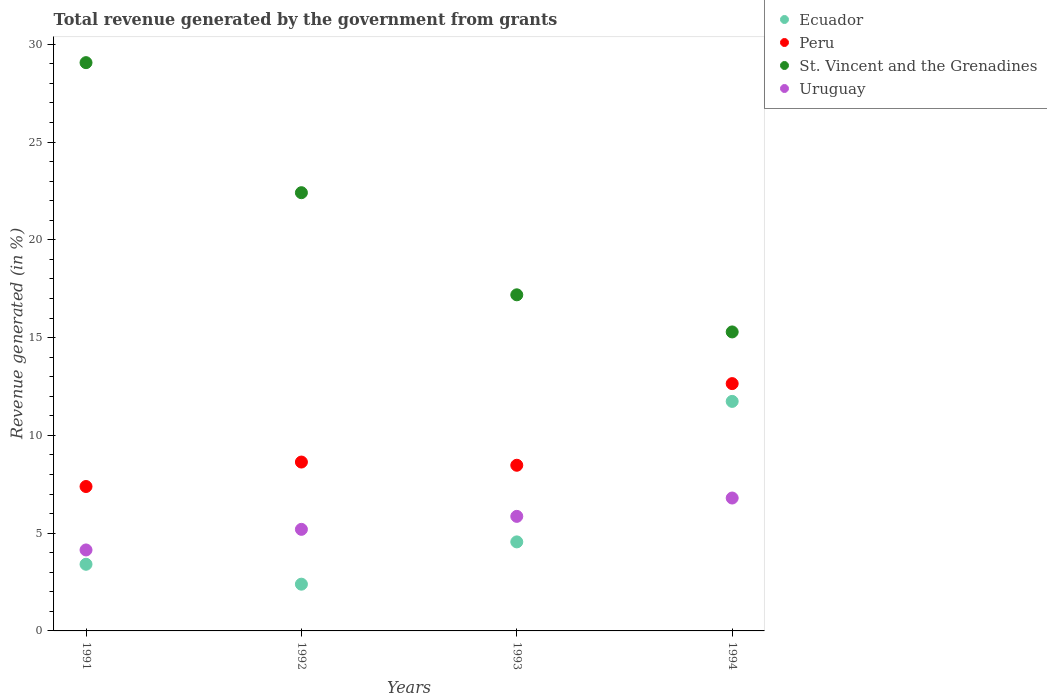How many different coloured dotlines are there?
Provide a succinct answer. 4. Is the number of dotlines equal to the number of legend labels?
Provide a short and direct response. Yes. What is the total revenue generated in Uruguay in 1991?
Your response must be concise. 4.14. Across all years, what is the maximum total revenue generated in Peru?
Make the answer very short. 12.65. Across all years, what is the minimum total revenue generated in St. Vincent and the Grenadines?
Your answer should be compact. 15.29. In which year was the total revenue generated in Ecuador minimum?
Your answer should be very brief. 1992. What is the total total revenue generated in Uruguay in the graph?
Make the answer very short. 21.99. What is the difference between the total revenue generated in St. Vincent and the Grenadines in 1991 and that in 1992?
Your response must be concise. 6.65. What is the difference between the total revenue generated in St. Vincent and the Grenadines in 1993 and the total revenue generated in Ecuador in 1991?
Offer a very short reply. 13.78. What is the average total revenue generated in Uruguay per year?
Offer a terse response. 5.5. In the year 1993, what is the difference between the total revenue generated in St. Vincent and the Grenadines and total revenue generated in Uruguay?
Your response must be concise. 11.33. In how many years, is the total revenue generated in St. Vincent and the Grenadines greater than 9 %?
Make the answer very short. 4. What is the ratio of the total revenue generated in Uruguay in 1991 to that in 1993?
Provide a short and direct response. 0.71. Is the total revenue generated in Peru in 1992 less than that in 1994?
Ensure brevity in your answer.  Yes. Is the difference between the total revenue generated in St. Vincent and the Grenadines in 1991 and 1993 greater than the difference between the total revenue generated in Uruguay in 1991 and 1993?
Ensure brevity in your answer.  Yes. What is the difference between the highest and the second highest total revenue generated in Uruguay?
Give a very brief answer. 0.94. What is the difference between the highest and the lowest total revenue generated in St. Vincent and the Grenadines?
Provide a succinct answer. 13.77. Is the sum of the total revenue generated in Peru in 1991 and 1992 greater than the maximum total revenue generated in St. Vincent and the Grenadines across all years?
Your answer should be very brief. No. Is the total revenue generated in Uruguay strictly less than the total revenue generated in Ecuador over the years?
Your response must be concise. No. How many dotlines are there?
Provide a short and direct response. 4. Does the graph contain any zero values?
Give a very brief answer. No. Does the graph contain grids?
Your answer should be compact. No. How many legend labels are there?
Offer a very short reply. 4. What is the title of the graph?
Your answer should be compact. Total revenue generated by the government from grants. What is the label or title of the X-axis?
Offer a very short reply. Years. What is the label or title of the Y-axis?
Ensure brevity in your answer.  Revenue generated (in %). What is the Revenue generated (in %) of Ecuador in 1991?
Keep it short and to the point. 3.41. What is the Revenue generated (in %) in Peru in 1991?
Your response must be concise. 7.38. What is the Revenue generated (in %) of St. Vincent and the Grenadines in 1991?
Keep it short and to the point. 29.06. What is the Revenue generated (in %) in Uruguay in 1991?
Provide a succinct answer. 4.14. What is the Revenue generated (in %) in Ecuador in 1992?
Keep it short and to the point. 2.39. What is the Revenue generated (in %) of Peru in 1992?
Provide a succinct answer. 8.64. What is the Revenue generated (in %) in St. Vincent and the Grenadines in 1992?
Your answer should be very brief. 22.41. What is the Revenue generated (in %) of Uruguay in 1992?
Offer a terse response. 5.19. What is the Revenue generated (in %) in Ecuador in 1993?
Keep it short and to the point. 4.55. What is the Revenue generated (in %) in Peru in 1993?
Your answer should be compact. 8.47. What is the Revenue generated (in %) of St. Vincent and the Grenadines in 1993?
Provide a short and direct response. 17.19. What is the Revenue generated (in %) in Uruguay in 1993?
Offer a terse response. 5.86. What is the Revenue generated (in %) in Ecuador in 1994?
Your answer should be compact. 11.74. What is the Revenue generated (in %) in Peru in 1994?
Provide a short and direct response. 12.65. What is the Revenue generated (in %) of St. Vincent and the Grenadines in 1994?
Your answer should be very brief. 15.29. What is the Revenue generated (in %) in Uruguay in 1994?
Your answer should be compact. 6.8. Across all years, what is the maximum Revenue generated (in %) of Ecuador?
Provide a short and direct response. 11.74. Across all years, what is the maximum Revenue generated (in %) of Peru?
Keep it short and to the point. 12.65. Across all years, what is the maximum Revenue generated (in %) of St. Vincent and the Grenadines?
Offer a terse response. 29.06. Across all years, what is the maximum Revenue generated (in %) in Uruguay?
Your answer should be compact. 6.8. Across all years, what is the minimum Revenue generated (in %) in Ecuador?
Your answer should be compact. 2.39. Across all years, what is the minimum Revenue generated (in %) of Peru?
Keep it short and to the point. 7.38. Across all years, what is the minimum Revenue generated (in %) of St. Vincent and the Grenadines?
Your answer should be compact. 15.29. Across all years, what is the minimum Revenue generated (in %) of Uruguay?
Your response must be concise. 4.14. What is the total Revenue generated (in %) of Ecuador in the graph?
Offer a very short reply. 22.09. What is the total Revenue generated (in %) in Peru in the graph?
Ensure brevity in your answer.  37.14. What is the total Revenue generated (in %) in St. Vincent and the Grenadines in the graph?
Your response must be concise. 83.95. What is the total Revenue generated (in %) of Uruguay in the graph?
Ensure brevity in your answer.  21.99. What is the difference between the Revenue generated (in %) of Ecuador in 1991 and that in 1992?
Keep it short and to the point. 1.02. What is the difference between the Revenue generated (in %) in Peru in 1991 and that in 1992?
Offer a terse response. -1.25. What is the difference between the Revenue generated (in %) in St. Vincent and the Grenadines in 1991 and that in 1992?
Ensure brevity in your answer.  6.65. What is the difference between the Revenue generated (in %) in Uruguay in 1991 and that in 1992?
Provide a short and direct response. -1.05. What is the difference between the Revenue generated (in %) of Ecuador in 1991 and that in 1993?
Your answer should be very brief. -1.14. What is the difference between the Revenue generated (in %) of Peru in 1991 and that in 1993?
Keep it short and to the point. -1.09. What is the difference between the Revenue generated (in %) of St. Vincent and the Grenadines in 1991 and that in 1993?
Offer a terse response. 11.87. What is the difference between the Revenue generated (in %) in Uruguay in 1991 and that in 1993?
Your answer should be compact. -1.72. What is the difference between the Revenue generated (in %) of Ecuador in 1991 and that in 1994?
Your answer should be compact. -8.33. What is the difference between the Revenue generated (in %) of Peru in 1991 and that in 1994?
Your response must be concise. -5.26. What is the difference between the Revenue generated (in %) in St. Vincent and the Grenadines in 1991 and that in 1994?
Keep it short and to the point. 13.77. What is the difference between the Revenue generated (in %) in Uruguay in 1991 and that in 1994?
Ensure brevity in your answer.  -2.66. What is the difference between the Revenue generated (in %) in Ecuador in 1992 and that in 1993?
Your answer should be compact. -2.16. What is the difference between the Revenue generated (in %) of Peru in 1992 and that in 1993?
Offer a very short reply. 0.16. What is the difference between the Revenue generated (in %) of St. Vincent and the Grenadines in 1992 and that in 1993?
Your answer should be compact. 5.22. What is the difference between the Revenue generated (in %) in Uruguay in 1992 and that in 1993?
Provide a short and direct response. -0.66. What is the difference between the Revenue generated (in %) of Ecuador in 1992 and that in 1994?
Offer a terse response. -9.35. What is the difference between the Revenue generated (in %) in Peru in 1992 and that in 1994?
Your answer should be compact. -4.01. What is the difference between the Revenue generated (in %) in St. Vincent and the Grenadines in 1992 and that in 1994?
Your answer should be compact. 7.12. What is the difference between the Revenue generated (in %) in Uruguay in 1992 and that in 1994?
Make the answer very short. -1.6. What is the difference between the Revenue generated (in %) in Ecuador in 1993 and that in 1994?
Give a very brief answer. -7.18. What is the difference between the Revenue generated (in %) in Peru in 1993 and that in 1994?
Your answer should be very brief. -4.18. What is the difference between the Revenue generated (in %) of St. Vincent and the Grenadines in 1993 and that in 1994?
Provide a short and direct response. 1.9. What is the difference between the Revenue generated (in %) of Uruguay in 1993 and that in 1994?
Give a very brief answer. -0.94. What is the difference between the Revenue generated (in %) of Ecuador in 1991 and the Revenue generated (in %) of Peru in 1992?
Provide a short and direct response. -5.23. What is the difference between the Revenue generated (in %) of Ecuador in 1991 and the Revenue generated (in %) of St. Vincent and the Grenadines in 1992?
Your answer should be very brief. -19. What is the difference between the Revenue generated (in %) of Ecuador in 1991 and the Revenue generated (in %) of Uruguay in 1992?
Keep it short and to the point. -1.79. What is the difference between the Revenue generated (in %) of Peru in 1991 and the Revenue generated (in %) of St. Vincent and the Grenadines in 1992?
Your response must be concise. -15.02. What is the difference between the Revenue generated (in %) in Peru in 1991 and the Revenue generated (in %) in Uruguay in 1992?
Offer a terse response. 2.19. What is the difference between the Revenue generated (in %) in St. Vincent and the Grenadines in 1991 and the Revenue generated (in %) in Uruguay in 1992?
Make the answer very short. 23.87. What is the difference between the Revenue generated (in %) in Ecuador in 1991 and the Revenue generated (in %) in Peru in 1993?
Ensure brevity in your answer.  -5.06. What is the difference between the Revenue generated (in %) of Ecuador in 1991 and the Revenue generated (in %) of St. Vincent and the Grenadines in 1993?
Keep it short and to the point. -13.78. What is the difference between the Revenue generated (in %) in Ecuador in 1991 and the Revenue generated (in %) in Uruguay in 1993?
Provide a succinct answer. -2.45. What is the difference between the Revenue generated (in %) of Peru in 1991 and the Revenue generated (in %) of St. Vincent and the Grenadines in 1993?
Your answer should be very brief. -9.8. What is the difference between the Revenue generated (in %) in Peru in 1991 and the Revenue generated (in %) in Uruguay in 1993?
Offer a terse response. 1.53. What is the difference between the Revenue generated (in %) in St. Vincent and the Grenadines in 1991 and the Revenue generated (in %) in Uruguay in 1993?
Keep it short and to the point. 23.2. What is the difference between the Revenue generated (in %) of Ecuador in 1991 and the Revenue generated (in %) of Peru in 1994?
Offer a very short reply. -9.24. What is the difference between the Revenue generated (in %) in Ecuador in 1991 and the Revenue generated (in %) in St. Vincent and the Grenadines in 1994?
Give a very brief answer. -11.88. What is the difference between the Revenue generated (in %) of Ecuador in 1991 and the Revenue generated (in %) of Uruguay in 1994?
Provide a short and direct response. -3.39. What is the difference between the Revenue generated (in %) in Peru in 1991 and the Revenue generated (in %) in St. Vincent and the Grenadines in 1994?
Provide a succinct answer. -7.9. What is the difference between the Revenue generated (in %) of Peru in 1991 and the Revenue generated (in %) of Uruguay in 1994?
Keep it short and to the point. 0.59. What is the difference between the Revenue generated (in %) of St. Vincent and the Grenadines in 1991 and the Revenue generated (in %) of Uruguay in 1994?
Give a very brief answer. 22.26. What is the difference between the Revenue generated (in %) in Ecuador in 1992 and the Revenue generated (in %) in Peru in 1993?
Keep it short and to the point. -6.08. What is the difference between the Revenue generated (in %) in Ecuador in 1992 and the Revenue generated (in %) in St. Vincent and the Grenadines in 1993?
Give a very brief answer. -14.8. What is the difference between the Revenue generated (in %) of Ecuador in 1992 and the Revenue generated (in %) of Uruguay in 1993?
Your answer should be very brief. -3.47. What is the difference between the Revenue generated (in %) in Peru in 1992 and the Revenue generated (in %) in St. Vincent and the Grenadines in 1993?
Your response must be concise. -8.55. What is the difference between the Revenue generated (in %) of Peru in 1992 and the Revenue generated (in %) of Uruguay in 1993?
Ensure brevity in your answer.  2.78. What is the difference between the Revenue generated (in %) in St. Vincent and the Grenadines in 1992 and the Revenue generated (in %) in Uruguay in 1993?
Provide a succinct answer. 16.55. What is the difference between the Revenue generated (in %) in Ecuador in 1992 and the Revenue generated (in %) in Peru in 1994?
Your answer should be very brief. -10.26. What is the difference between the Revenue generated (in %) of Ecuador in 1992 and the Revenue generated (in %) of St. Vincent and the Grenadines in 1994?
Your answer should be very brief. -12.9. What is the difference between the Revenue generated (in %) of Ecuador in 1992 and the Revenue generated (in %) of Uruguay in 1994?
Offer a very short reply. -4.41. What is the difference between the Revenue generated (in %) in Peru in 1992 and the Revenue generated (in %) in St. Vincent and the Grenadines in 1994?
Ensure brevity in your answer.  -6.65. What is the difference between the Revenue generated (in %) of Peru in 1992 and the Revenue generated (in %) of Uruguay in 1994?
Your response must be concise. 1.84. What is the difference between the Revenue generated (in %) in St. Vincent and the Grenadines in 1992 and the Revenue generated (in %) in Uruguay in 1994?
Provide a succinct answer. 15.61. What is the difference between the Revenue generated (in %) of Ecuador in 1993 and the Revenue generated (in %) of Peru in 1994?
Keep it short and to the point. -8.09. What is the difference between the Revenue generated (in %) of Ecuador in 1993 and the Revenue generated (in %) of St. Vincent and the Grenadines in 1994?
Ensure brevity in your answer.  -10.74. What is the difference between the Revenue generated (in %) in Ecuador in 1993 and the Revenue generated (in %) in Uruguay in 1994?
Make the answer very short. -2.24. What is the difference between the Revenue generated (in %) of Peru in 1993 and the Revenue generated (in %) of St. Vincent and the Grenadines in 1994?
Offer a very short reply. -6.82. What is the difference between the Revenue generated (in %) in Peru in 1993 and the Revenue generated (in %) in Uruguay in 1994?
Your response must be concise. 1.68. What is the difference between the Revenue generated (in %) of St. Vincent and the Grenadines in 1993 and the Revenue generated (in %) of Uruguay in 1994?
Ensure brevity in your answer.  10.39. What is the average Revenue generated (in %) in Ecuador per year?
Keep it short and to the point. 5.52. What is the average Revenue generated (in %) of Peru per year?
Make the answer very short. 9.28. What is the average Revenue generated (in %) in St. Vincent and the Grenadines per year?
Provide a succinct answer. 20.99. What is the average Revenue generated (in %) in Uruguay per year?
Give a very brief answer. 5.5. In the year 1991, what is the difference between the Revenue generated (in %) of Ecuador and Revenue generated (in %) of Peru?
Your answer should be very brief. -3.98. In the year 1991, what is the difference between the Revenue generated (in %) in Ecuador and Revenue generated (in %) in St. Vincent and the Grenadines?
Your response must be concise. -25.65. In the year 1991, what is the difference between the Revenue generated (in %) of Ecuador and Revenue generated (in %) of Uruguay?
Keep it short and to the point. -0.73. In the year 1991, what is the difference between the Revenue generated (in %) of Peru and Revenue generated (in %) of St. Vincent and the Grenadines?
Ensure brevity in your answer.  -21.67. In the year 1991, what is the difference between the Revenue generated (in %) of Peru and Revenue generated (in %) of Uruguay?
Your answer should be very brief. 3.24. In the year 1991, what is the difference between the Revenue generated (in %) in St. Vincent and the Grenadines and Revenue generated (in %) in Uruguay?
Offer a very short reply. 24.92. In the year 1992, what is the difference between the Revenue generated (in %) in Ecuador and Revenue generated (in %) in Peru?
Give a very brief answer. -6.25. In the year 1992, what is the difference between the Revenue generated (in %) in Ecuador and Revenue generated (in %) in St. Vincent and the Grenadines?
Make the answer very short. -20.02. In the year 1992, what is the difference between the Revenue generated (in %) in Ecuador and Revenue generated (in %) in Uruguay?
Provide a short and direct response. -2.8. In the year 1992, what is the difference between the Revenue generated (in %) in Peru and Revenue generated (in %) in St. Vincent and the Grenadines?
Give a very brief answer. -13.77. In the year 1992, what is the difference between the Revenue generated (in %) in Peru and Revenue generated (in %) in Uruguay?
Your answer should be very brief. 3.44. In the year 1992, what is the difference between the Revenue generated (in %) in St. Vincent and the Grenadines and Revenue generated (in %) in Uruguay?
Provide a succinct answer. 17.21. In the year 1993, what is the difference between the Revenue generated (in %) of Ecuador and Revenue generated (in %) of Peru?
Make the answer very short. -3.92. In the year 1993, what is the difference between the Revenue generated (in %) in Ecuador and Revenue generated (in %) in St. Vincent and the Grenadines?
Provide a succinct answer. -12.63. In the year 1993, what is the difference between the Revenue generated (in %) of Ecuador and Revenue generated (in %) of Uruguay?
Ensure brevity in your answer.  -1.31. In the year 1993, what is the difference between the Revenue generated (in %) of Peru and Revenue generated (in %) of St. Vincent and the Grenadines?
Offer a terse response. -8.72. In the year 1993, what is the difference between the Revenue generated (in %) in Peru and Revenue generated (in %) in Uruguay?
Provide a succinct answer. 2.61. In the year 1993, what is the difference between the Revenue generated (in %) of St. Vincent and the Grenadines and Revenue generated (in %) of Uruguay?
Keep it short and to the point. 11.33. In the year 1994, what is the difference between the Revenue generated (in %) in Ecuador and Revenue generated (in %) in Peru?
Offer a very short reply. -0.91. In the year 1994, what is the difference between the Revenue generated (in %) in Ecuador and Revenue generated (in %) in St. Vincent and the Grenadines?
Give a very brief answer. -3.55. In the year 1994, what is the difference between the Revenue generated (in %) of Ecuador and Revenue generated (in %) of Uruguay?
Your answer should be very brief. 4.94. In the year 1994, what is the difference between the Revenue generated (in %) in Peru and Revenue generated (in %) in St. Vincent and the Grenadines?
Provide a succinct answer. -2.64. In the year 1994, what is the difference between the Revenue generated (in %) of Peru and Revenue generated (in %) of Uruguay?
Make the answer very short. 5.85. In the year 1994, what is the difference between the Revenue generated (in %) in St. Vincent and the Grenadines and Revenue generated (in %) in Uruguay?
Make the answer very short. 8.49. What is the ratio of the Revenue generated (in %) in Ecuador in 1991 to that in 1992?
Provide a succinct answer. 1.43. What is the ratio of the Revenue generated (in %) of Peru in 1991 to that in 1992?
Provide a short and direct response. 0.86. What is the ratio of the Revenue generated (in %) in St. Vincent and the Grenadines in 1991 to that in 1992?
Your answer should be very brief. 1.3. What is the ratio of the Revenue generated (in %) of Uruguay in 1991 to that in 1992?
Offer a terse response. 0.8. What is the ratio of the Revenue generated (in %) of Ecuador in 1991 to that in 1993?
Your answer should be compact. 0.75. What is the ratio of the Revenue generated (in %) of Peru in 1991 to that in 1993?
Your answer should be compact. 0.87. What is the ratio of the Revenue generated (in %) of St. Vincent and the Grenadines in 1991 to that in 1993?
Keep it short and to the point. 1.69. What is the ratio of the Revenue generated (in %) in Uruguay in 1991 to that in 1993?
Provide a succinct answer. 0.71. What is the ratio of the Revenue generated (in %) in Ecuador in 1991 to that in 1994?
Make the answer very short. 0.29. What is the ratio of the Revenue generated (in %) of Peru in 1991 to that in 1994?
Offer a very short reply. 0.58. What is the ratio of the Revenue generated (in %) in St. Vincent and the Grenadines in 1991 to that in 1994?
Your answer should be compact. 1.9. What is the ratio of the Revenue generated (in %) of Uruguay in 1991 to that in 1994?
Ensure brevity in your answer.  0.61. What is the ratio of the Revenue generated (in %) of Ecuador in 1992 to that in 1993?
Keep it short and to the point. 0.53. What is the ratio of the Revenue generated (in %) of Peru in 1992 to that in 1993?
Offer a terse response. 1.02. What is the ratio of the Revenue generated (in %) in St. Vincent and the Grenadines in 1992 to that in 1993?
Ensure brevity in your answer.  1.3. What is the ratio of the Revenue generated (in %) of Uruguay in 1992 to that in 1993?
Ensure brevity in your answer.  0.89. What is the ratio of the Revenue generated (in %) in Ecuador in 1992 to that in 1994?
Offer a very short reply. 0.2. What is the ratio of the Revenue generated (in %) of Peru in 1992 to that in 1994?
Provide a short and direct response. 0.68. What is the ratio of the Revenue generated (in %) in St. Vincent and the Grenadines in 1992 to that in 1994?
Offer a terse response. 1.47. What is the ratio of the Revenue generated (in %) in Uruguay in 1992 to that in 1994?
Make the answer very short. 0.76. What is the ratio of the Revenue generated (in %) of Ecuador in 1993 to that in 1994?
Provide a succinct answer. 0.39. What is the ratio of the Revenue generated (in %) in Peru in 1993 to that in 1994?
Offer a terse response. 0.67. What is the ratio of the Revenue generated (in %) of St. Vincent and the Grenadines in 1993 to that in 1994?
Provide a succinct answer. 1.12. What is the ratio of the Revenue generated (in %) in Uruguay in 1993 to that in 1994?
Offer a terse response. 0.86. What is the difference between the highest and the second highest Revenue generated (in %) in Ecuador?
Offer a very short reply. 7.18. What is the difference between the highest and the second highest Revenue generated (in %) of Peru?
Your answer should be compact. 4.01. What is the difference between the highest and the second highest Revenue generated (in %) in St. Vincent and the Grenadines?
Provide a short and direct response. 6.65. What is the difference between the highest and the second highest Revenue generated (in %) in Uruguay?
Offer a very short reply. 0.94. What is the difference between the highest and the lowest Revenue generated (in %) in Ecuador?
Offer a terse response. 9.35. What is the difference between the highest and the lowest Revenue generated (in %) of Peru?
Your response must be concise. 5.26. What is the difference between the highest and the lowest Revenue generated (in %) of St. Vincent and the Grenadines?
Give a very brief answer. 13.77. What is the difference between the highest and the lowest Revenue generated (in %) of Uruguay?
Make the answer very short. 2.66. 